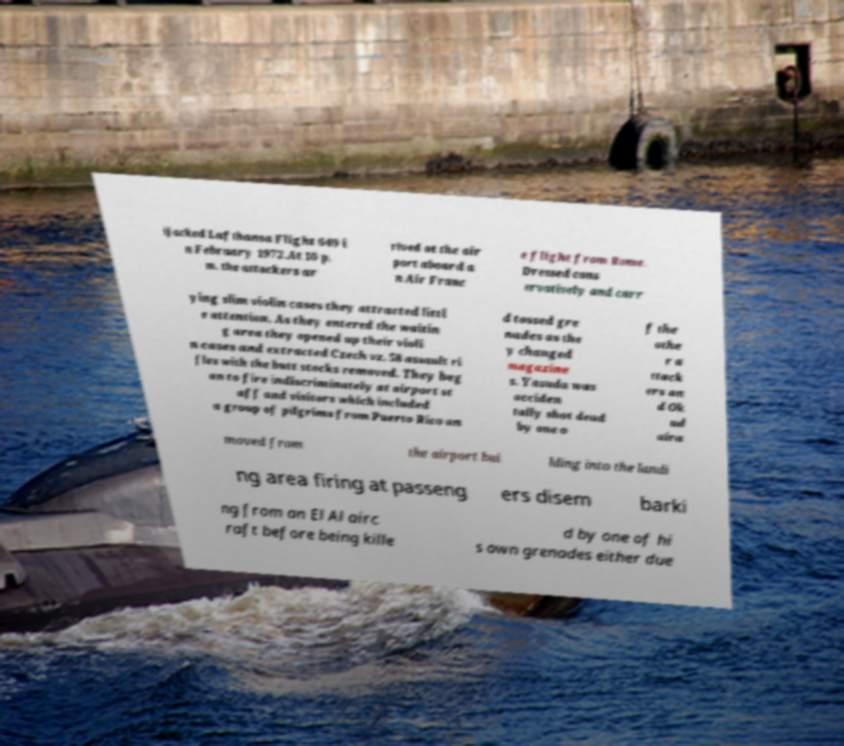Could you extract and type out the text from this image? ijacked Lufthansa Flight 649 i n February 1972.At 10 p. m. the attackers ar rived at the air port aboard a n Air Franc e flight from Rome. Dressed cons ervatively and carr ying slim violin cases they attracted littl e attention. As they entered the waitin g area they opened up their violi n cases and extracted Czech vz. 58 assault ri fles with the butt stocks removed. They beg an to fire indiscriminately at airport st aff and visitors which included a group of pilgrims from Puerto Rico an d tossed gre nades as the y changed magazine s. Yasuda was acciden tally shot dead by one o f the othe r a ttack ers an d Ok ud aira moved from the airport bui lding into the landi ng area firing at passeng ers disem barki ng from an El Al airc raft before being kille d by one of hi s own grenades either due 